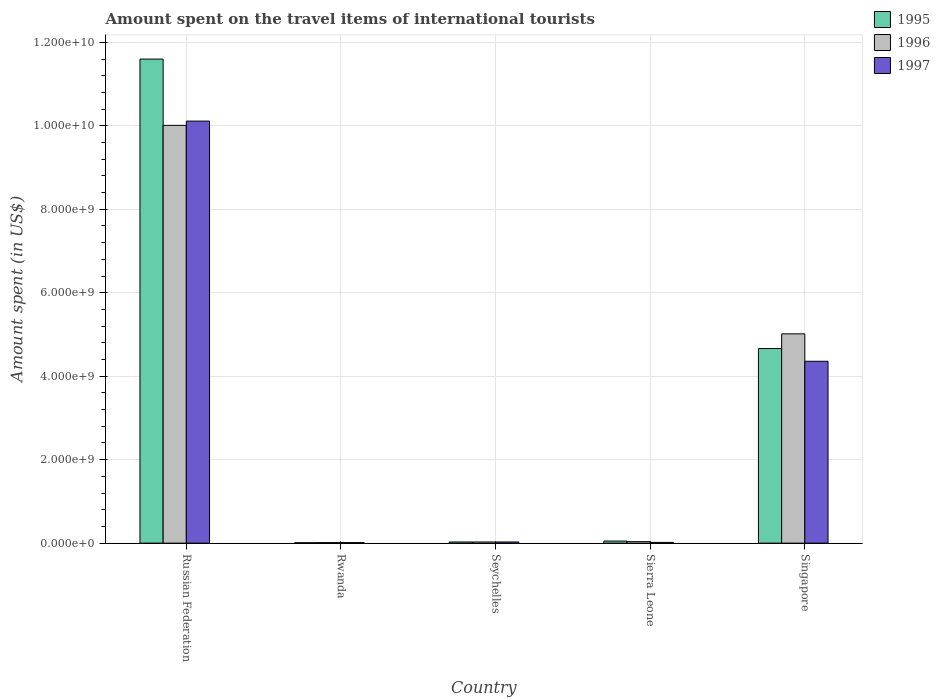How many different coloured bars are there?
Your response must be concise. 3. How many bars are there on the 1st tick from the right?
Your response must be concise. 3. What is the label of the 5th group of bars from the left?
Offer a terse response. Singapore. In how many cases, is the number of bars for a given country not equal to the number of legend labels?
Ensure brevity in your answer.  0. What is the amount spent on the travel items of international tourists in 1995 in Russian Federation?
Ensure brevity in your answer.  1.16e+1. Across all countries, what is the maximum amount spent on the travel items of international tourists in 1996?
Give a very brief answer. 1.00e+1. Across all countries, what is the minimum amount spent on the travel items of international tourists in 1995?
Your answer should be compact. 1.00e+07. In which country was the amount spent on the travel items of international tourists in 1995 maximum?
Your answer should be compact. Russian Federation. In which country was the amount spent on the travel items of international tourists in 1995 minimum?
Your answer should be compact. Rwanda. What is the total amount spent on the travel items of international tourists in 1997 in the graph?
Provide a succinct answer. 1.45e+1. What is the difference between the amount spent on the travel items of international tourists in 1997 in Seychelles and that in Singapore?
Make the answer very short. -4.33e+09. What is the difference between the amount spent on the travel items of international tourists in 1996 in Sierra Leone and the amount spent on the travel items of international tourists in 1997 in Russian Federation?
Your answer should be very brief. -1.01e+1. What is the average amount spent on the travel items of international tourists in 1995 per country?
Provide a succinct answer. 3.27e+09. In how many countries, is the amount spent on the travel items of international tourists in 1996 greater than 11200000000 US$?
Your answer should be compact. 0. What is the ratio of the amount spent on the travel items of international tourists in 1996 in Rwanda to that in Sierra Leone?
Offer a terse response. 0.36. What is the difference between the highest and the second highest amount spent on the travel items of international tourists in 1997?
Provide a succinct answer. 1.01e+1. What is the difference between the highest and the lowest amount spent on the travel items of international tourists in 1997?
Offer a terse response. 1.01e+1. In how many countries, is the amount spent on the travel items of international tourists in 1995 greater than the average amount spent on the travel items of international tourists in 1995 taken over all countries?
Keep it short and to the point. 2. Is the sum of the amount spent on the travel items of international tourists in 1997 in Sierra Leone and Singapore greater than the maximum amount spent on the travel items of international tourists in 1996 across all countries?
Your answer should be very brief. No. What does the 1st bar from the left in Russian Federation represents?
Offer a very short reply. 1995. What does the 2nd bar from the right in Seychelles represents?
Ensure brevity in your answer.  1996. Is it the case that in every country, the sum of the amount spent on the travel items of international tourists in 1995 and amount spent on the travel items of international tourists in 1997 is greater than the amount spent on the travel items of international tourists in 1996?
Provide a succinct answer. Yes. Are all the bars in the graph horizontal?
Provide a succinct answer. No. Are the values on the major ticks of Y-axis written in scientific E-notation?
Your answer should be very brief. Yes. How are the legend labels stacked?
Make the answer very short. Vertical. What is the title of the graph?
Offer a very short reply. Amount spent on the travel items of international tourists. What is the label or title of the Y-axis?
Your answer should be compact. Amount spent (in US$). What is the Amount spent (in US$) of 1995 in Russian Federation?
Keep it short and to the point. 1.16e+1. What is the Amount spent (in US$) of 1996 in Russian Federation?
Make the answer very short. 1.00e+1. What is the Amount spent (in US$) in 1997 in Russian Federation?
Provide a succinct answer. 1.01e+1. What is the Amount spent (in US$) of 1996 in Rwanda?
Give a very brief answer. 1.30e+07. What is the Amount spent (in US$) in 1997 in Rwanda?
Your answer should be very brief. 1.30e+07. What is the Amount spent (in US$) in 1995 in Seychelles?
Your answer should be very brief. 2.80e+07. What is the Amount spent (in US$) of 1996 in Seychelles?
Keep it short and to the point. 2.80e+07. What is the Amount spent (in US$) in 1997 in Seychelles?
Make the answer very short. 2.80e+07. What is the Amount spent (in US$) of 1996 in Sierra Leone?
Give a very brief answer. 3.60e+07. What is the Amount spent (in US$) of 1997 in Sierra Leone?
Make the answer very short. 1.80e+07. What is the Amount spent (in US$) in 1995 in Singapore?
Ensure brevity in your answer.  4.66e+09. What is the Amount spent (in US$) of 1996 in Singapore?
Your response must be concise. 5.02e+09. What is the Amount spent (in US$) of 1997 in Singapore?
Your answer should be very brief. 4.36e+09. Across all countries, what is the maximum Amount spent (in US$) of 1995?
Offer a very short reply. 1.16e+1. Across all countries, what is the maximum Amount spent (in US$) in 1996?
Provide a short and direct response. 1.00e+1. Across all countries, what is the maximum Amount spent (in US$) of 1997?
Give a very brief answer. 1.01e+1. Across all countries, what is the minimum Amount spent (in US$) in 1996?
Provide a succinct answer. 1.30e+07. Across all countries, what is the minimum Amount spent (in US$) in 1997?
Give a very brief answer. 1.30e+07. What is the total Amount spent (in US$) in 1995 in the graph?
Make the answer very short. 1.64e+1. What is the total Amount spent (in US$) in 1996 in the graph?
Give a very brief answer. 1.51e+1. What is the total Amount spent (in US$) in 1997 in the graph?
Your response must be concise. 1.45e+1. What is the difference between the Amount spent (in US$) in 1995 in Russian Federation and that in Rwanda?
Your answer should be very brief. 1.16e+1. What is the difference between the Amount spent (in US$) in 1996 in Russian Federation and that in Rwanda?
Provide a short and direct response. 1.00e+1. What is the difference between the Amount spent (in US$) in 1997 in Russian Federation and that in Rwanda?
Your response must be concise. 1.01e+1. What is the difference between the Amount spent (in US$) in 1995 in Russian Federation and that in Seychelles?
Provide a succinct answer. 1.16e+1. What is the difference between the Amount spent (in US$) of 1996 in Russian Federation and that in Seychelles?
Offer a very short reply. 9.98e+09. What is the difference between the Amount spent (in US$) of 1997 in Russian Federation and that in Seychelles?
Provide a short and direct response. 1.01e+1. What is the difference between the Amount spent (in US$) of 1995 in Russian Federation and that in Sierra Leone?
Your answer should be compact. 1.15e+1. What is the difference between the Amount spent (in US$) of 1996 in Russian Federation and that in Sierra Leone?
Provide a succinct answer. 9.98e+09. What is the difference between the Amount spent (in US$) in 1997 in Russian Federation and that in Sierra Leone?
Keep it short and to the point. 1.01e+1. What is the difference between the Amount spent (in US$) in 1995 in Russian Federation and that in Singapore?
Your response must be concise. 6.94e+09. What is the difference between the Amount spent (in US$) of 1996 in Russian Federation and that in Singapore?
Your answer should be compact. 5.00e+09. What is the difference between the Amount spent (in US$) in 1997 in Russian Federation and that in Singapore?
Give a very brief answer. 5.76e+09. What is the difference between the Amount spent (in US$) in 1995 in Rwanda and that in Seychelles?
Your response must be concise. -1.80e+07. What is the difference between the Amount spent (in US$) of 1996 in Rwanda and that in Seychelles?
Give a very brief answer. -1.50e+07. What is the difference between the Amount spent (in US$) in 1997 in Rwanda and that in Seychelles?
Your answer should be compact. -1.50e+07. What is the difference between the Amount spent (in US$) of 1995 in Rwanda and that in Sierra Leone?
Offer a very short reply. -4.00e+07. What is the difference between the Amount spent (in US$) of 1996 in Rwanda and that in Sierra Leone?
Provide a succinct answer. -2.30e+07. What is the difference between the Amount spent (in US$) in 1997 in Rwanda and that in Sierra Leone?
Provide a short and direct response. -5.00e+06. What is the difference between the Amount spent (in US$) in 1995 in Rwanda and that in Singapore?
Give a very brief answer. -4.65e+09. What is the difference between the Amount spent (in US$) of 1996 in Rwanda and that in Singapore?
Your answer should be compact. -5.00e+09. What is the difference between the Amount spent (in US$) in 1997 in Rwanda and that in Singapore?
Make the answer very short. -4.34e+09. What is the difference between the Amount spent (in US$) in 1995 in Seychelles and that in Sierra Leone?
Keep it short and to the point. -2.20e+07. What is the difference between the Amount spent (in US$) in 1996 in Seychelles and that in Sierra Leone?
Make the answer very short. -8.00e+06. What is the difference between the Amount spent (in US$) of 1995 in Seychelles and that in Singapore?
Offer a very short reply. -4.64e+09. What is the difference between the Amount spent (in US$) in 1996 in Seychelles and that in Singapore?
Offer a terse response. -4.99e+09. What is the difference between the Amount spent (in US$) of 1997 in Seychelles and that in Singapore?
Your answer should be very brief. -4.33e+09. What is the difference between the Amount spent (in US$) in 1995 in Sierra Leone and that in Singapore?
Make the answer very short. -4.61e+09. What is the difference between the Amount spent (in US$) of 1996 in Sierra Leone and that in Singapore?
Provide a short and direct response. -4.98e+09. What is the difference between the Amount spent (in US$) of 1997 in Sierra Leone and that in Singapore?
Your response must be concise. -4.34e+09. What is the difference between the Amount spent (in US$) in 1995 in Russian Federation and the Amount spent (in US$) in 1996 in Rwanda?
Provide a short and direct response. 1.16e+1. What is the difference between the Amount spent (in US$) of 1995 in Russian Federation and the Amount spent (in US$) of 1997 in Rwanda?
Offer a terse response. 1.16e+1. What is the difference between the Amount spent (in US$) in 1996 in Russian Federation and the Amount spent (in US$) in 1997 in Rwanda?
Offer a very short reply. 1.00e+1. What is the difference between the Amount spent (in US$) in 1995 in Russian Federation and the Amount spent (in US$) in 1996 in Seychelles?
Offer a very short reply. 1.16e+1. What is the difference between the Amount spent (in US$) of 1995 in Russian Federation and the Amount spent (in US$) of 1997 in Seychelles?
Make the answer very short. 1.16e+1. What is the difference between the Amount spent (in US$) in 1996 in Russian Federation and the Amount spent (in US$) in 1997 in Seychelles?
Provide a short and direct response. 9.98e+09. What is the difference between the Amount spent (in US$) in 1995 in Russian Federation and the Amount spent (in US$) in 1996 in Sierra Leone?
Offer a terse response. 1.16e+1. What is the difference between the Amount spent (in US$) in 1995 in Russian Federation and the Amount spent (in US$) in 1997 in Sierra Leone?
Keep it short and to the point. 1.16e+1. What is the difference between the Amount spent (in US$) in 1996 in Russian Federation and the Amount spent (in US$) in 1997 in Sierra Leone?
Your response must be concise. 9.99e+09. What is the difference between the Amount spent (in US$) in 1995 in Russian Federation and the Amount spent (in US$) in 1996 in Singapore?
Give a very brief answer. 6.58e+09. What is the difference between the Amount spent (in US$) in 1995 in Russian Federation and the Amount spent (in US$) in 1997 in Singapore?
Your answer should be compact. 7.24e+09. What is the difference between the Amount spent (in US$) in 1996 in Russian Federation and the Amount spent (in US$) in 1997 in Singapore?
Ensure brevity in your answer.  5.65e+09. What is the difference between the Amount spent (in US$) in 1995 in Rwanda and the Amount spent (in US$) in 1996 in Seychelles?
Provide a succinct answer. -1.80e+07. What is the difference between the Amount spent (in US$) of 1995 in Rwanda and the Amount spent (in US$) of 1997 in Seychelles?
Your answer should be very brief. -1.80e+07. What is the difference between the Amount spent (in US$) of 1996 in Rwanda and the Amount spent (in US$) of 1997 in Seychelles?
Give a very brief answer. -1.50e+07. What is the difference between the Amount spent (in US$) in 1995 in Rwanda and the Amount spent (in US$) in 1996 in Sierra Leone?
Provide a short and direct response. -2.60e+07. What is the difference between the Amount spent (in US$) of 1995 in Rwanda and the Amount spent (in US$) of 1997 in Sierra Leone?
Ensure brevity in your answer.  -8.00e+06. What is the difference between the Amount spent (in US$) of 1996 in Rwanda and the Amount spent (in US$) of 1997 in Sierra Leone?
Offer a very short reply. -5.00e+06. What is the difference between the Amount spent (in US$) in 1995 in Rwanda and the Amount spent (in US$) in 1996 in Singapore?
Offer a very short reply. -5.00e+09. What is the difference between the Amount spent (in US$) of 1995 in Rwanda and the Amount spent (in US$) of 1997 in Singapore?
Offer a very short reply. -4.35e+09. What is the difference between the Amount spent (in US$) in 1996 in Rwanda and the Amount spent (in US$) in 1997 in Singapore?
Ensure brevity in your answer.  -4.34e+09. What is the difference between the Amount spent (in US$) in 1995 in Seychelles and the Amount spent (in US$) in 1996 in Sierra Leone?
Your answer should be compact. -8.00e+06. What is the difference between the Amount spent (in US$) in 1995 in Seychelles and the Amount spent (in US$) in 1997 in Sierra Leone?
Your answer should be compact. 1.00e+07. What is the difference between the Amount spent (in US$) in 1996 in Seychelles and the Amount spent (in US$) in 1997 in Sierra Leone?
Your answer should be compact. 1.00e+07. What is the difference between the Amount spent (in US$) of 1995 in Seychelles and the Amount spent (in US$) of 1996 in Singapore?
Your answer should be compact. -4.99e+09. What is the difference between the Amount spent (in US$) of 1995 in Seychelles and the Amount spent (in US$) of 1997 in Singapore?
Your answer should be compact. -4.33e+09. What is the difference between the Amount spent (in US$) of 1996 in Seychelles and the Amount spent (in US$) of 1997 in Singapore?
Your response must be concise. -4.33e+09. What is the difference between the Amount spent (in US$) in 1995 in Sierra Leone and the Amount spent (in US$) in 1996 in Singapore?
Give a very brief answer. -4.96e+09. What is the difference between the Amount spent (in US$) in 1995 in Sierra Leone and the Amount spent (in US$) in 1997 in Singapore?
Ensure brevity in your answer.  -4.31e+09. What is the difference between the Amount spent (in US$) in 1996 in Sierra Leone and the Amount spent (in US$) in 1997 in Singapore?
Your answer should be compact. -4.32e+09. What is the average Amount spent (in US$) of 1995 per country?
Offer a very short reply. 3.27e+09. What is the average Amount spent (in US$) of 1996 per country?
Give a very brief answer. 3.02e+09. What is the average Amount spent (in US$) in 1997 per country?
Offer a very short reply. 2.91e+09. What is the difference between the Amount spent (in US$) of 1995 and Amount spent (in US$) of 1996 in Russian Federation?
Provide a short and direct response. 1.59e+09. What is the difference between the Amount spent (in US$) of 1995 and Amount spent (in US$) of 1997 in Russian Federation?
Offer a terse response. 1.49e+09. What is the difference between the Amount spent (in US$) of 1996 and Amount spent (in US$) of 1997 in Russian Federation?
Provide a short and direct response. -1.02e+08. What is the difference between the Amount spent (in US$) in 1996 and Amount spent (in US$) in 1997 in Rwanda?
Your response must be concise. 0. What is the difference between the Amount spent (in US$) of 1995 and Amount spent (in US$) of 1996 in Seychelles?
Make the answer very short. 0. What is the difference between the Amount spent (in US$) in 1995 and Amount spent (in US$) in 1997 in Seychelles?
Offer a very short reply. 0. What is the difference between the Amount spent (in US$) in 1996 and Amount spent (in US$) in 1997 in Seychelles?
Your answer should be very brief. 0. What is the difference between the Amount spent (in US$) in 1995 and Amount spent (in US$) in 1996 in Sierra Leone?
Provide a succinct answer. 1.40e+07. What is the difference between the Amount spent (in US$) in 1995 and Amount spent (in US$) in 1997 in Sierra Leone?
Offer a very short reply. 3.20e+07. What is the difference between the Amount spent (in US$) in 1996 and Amount spent (in US$) in 1997 in Sierra Leone?
Ensure brevity in your answer.  1.80e+07. What is the difference between the Amount spent (in US$) in 1995 and Amount spent (in US$) in 1996 in Singapore?
Your answer should be compact. -3.52e+08. What is the difference between the Amount spent (in US$) of 1995 and Amount spent (in US$) of 1997 in Singapore?
Offer a terse response. 3.05e+08. What is the difference between the Amount spent (in US$) in 1996 and Amount spent (in US$) in 1997 in Singapore?
Your answer should be very brief. 6.57e+08. What is the ratio of the Amount spent (in US$) of 1995 in Russian Federation to that in Rwanda?
Your response must be concise. 1159.9. What is the ratio of the Amount spent (in US$) of 1996 in Russian Federation to that in Rwanda?
Offer a very short reply. 770.08. What is the ratio of the Amount spent (in US$) of 1997 in Russian Federation to that in Rwanda?
Offer a very short reply. 777.92. What is the ratio of the Amount spent (in US$) in 1995 in Russian Federation to that in Seychelles?
Offer a terse response. 414.25. What is the ratio of the Amount spent (in US$) of 1996 in Russian Federation to that in Seychelles?
Give a very brief answer. 357.54. What is the ratio of the Amount spent (in US$) of 1997 in Russian Federation to that in Seychelles?
Make the answer very short. 361.18. What is the ratio of the Amount spent (in US$) in 1995 in Russian Federation to that in Sierra Leone?
Your answer should be very brief. 231.98. What is the ratio of the Amount spent (in US$) in 1996 in Russian Federation to that in Sierra Leone?
Your response must be concise. 278.08. What is the ratio of the Amount spent (in US$) of 1997 in Russian Federation to that in Sierra Leone?
Give a very brief answer. 561.83. What is the ratio of the Amount spent (in US$) of 1995 in Russian Federation to that in Singapore?
Provide a succinct answer. 2.49. What is the ratio of the Amount spent (in US$) of 1996 in Russian Federation to that in Singapore?
Provide a succinct answer. 2. What is the ratio of the Amount spent (in US$) of 1997 in Russian Federation to that in Singapore?
Offer a terse response. 2.32. What is the ratio of the Amount spent (in US$) of 1995 in Rwanda to that in Seychelles?
Make the answer very short. 0.36. What is the ratio of the Amount spent (in US$) in 1996 in Rwanda to that in Seychelles?
Provide a short and direct response. 0.46. What is the ratio of the Amount spent (in US$) of 1997 in Rwanda to that in Seychelles?
Your answer should be very brief. 0.46. What is the ratio of the Amount spent (in US$) of 1996 in Rwanda to that in Sierra Leone?
Offer a terse response. 0.36. What is the ratio of the Amount spent (in US$) in 1997 in Rwanda to that in Sierra Leone?
Give a very brief answer. 0.72. What is the ratio of the Amount spent (in US$) in 1995 in Rwanda to that in Singapore?
Keep it short and to the point. 0. What is the ratio of the Amount spent (in US$) in 1996 in Rwanda to that in Singapore?
Ensure brevity in your answer.  0. What is the ratio of the Amount spent (in US$) of 1997 in Rwanda to that in Singapore?
Offer a terse response. 0. What is the ratio of the Amount spent (in US$) in 1995 in Seychelles to that in Sierra Leone?
Your answer should be very brief. 0.56. What is the ratio of the Amount spent (in US$) of 1997 in Seychelles to that in Sierra Leone?
Keep it short and to the point. 1.56. What is the ratio of the Amount spent (in US$) of 1995 in Seychelles to that in Singapore?
Offer a terse response. 0.01. What is the ratio of the Amount spent (in US$) in 1996 in Seychelles to that in Singapore?
Make the answer very short. 0.01. What is the ratio of the Amount spent (in US$) in 1997 in Seychelles to that in Singapore?
Provide a short and direct response. 0.01. What is the ratio of the Amount spent (in US$) of 1995 in Sierra Leone to that in Singapore?
Offer a terse response. 0.01. What is the ratio of the Amount spent (in US$) of 1996 in Sierra Leone to that in Singapore?
Keep it short and to the point. 0.01. What is the ratio of the Amount spent (in US$) in 1997 in Sierra Leone to that in Singapore?
Your answer should be very brief. 0. What is the difference between the highest and the second highest Amount spent (in US$) in 1995?
Make the answer very short. 6.94e+09. What is the difference between the highest and the second highest Amount spent (in US$) of 1996?
Give a very brief answer. 5.00e+09. What is the difference between the highest and the second highest Amount spent (in US$) in 1997?
Make the answer very short. 5.76e+09. What is the difference between the highest and the lowest Amount spent (in US$) in 1995?
Your answer should be very brief. 1.16e+1. What is the difference between the highest and the lowest Amount spent (in US$) in 1996?
Your answer should be very brief. 1.00e+1. What is the difference between the highest and the lowest Amount spent (in US$) of 1997?
Your answer should be very brief. 1.01e+1. 